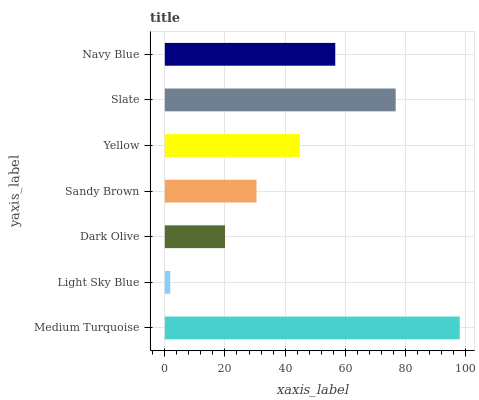Is Light Sky Blue the minimum?
Answer yes or no. Yes. Is Medium Turquoise the maximum?
Answer yes or no. Yes. Is Dark Olive the minimum?
Answer yes or no. No. Is Dark Olive the maximum?
Answer yes or no. No. Is Dark Olive greater than Light Sky Blue?
Answer yes or no. Yes. Is Light Sky Blue less than Dark Olive?
Answer yes or no. Yes. Is Light Sky Blue greater than Dark Olive?
Answer yes or no. No. Is Dark Olive less than Light Sky Blue?
Answer yes or no. No. Is Yellow the high median?
Answer yes or no. Yes. Is Yellow the low median?
Answer yes or no. Yes. Is Sandy Brown the high median?
Answer yes or no. No. Is Slate the low median?
Answer yes or no. No. 